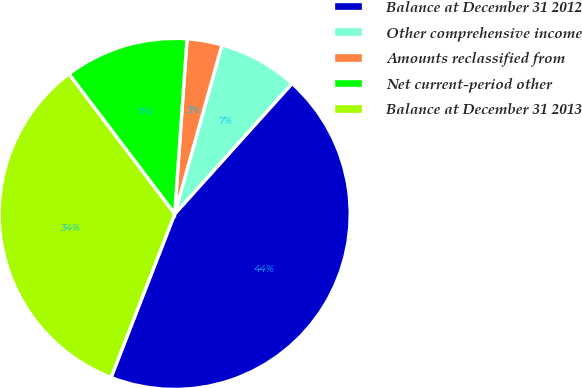<chart> <loc_0><loc_0><loc_500><loc_500><pie_chart><fcel>Balance at December 31 2012<fcel>Other comprehensive income<fcel>Amounts reclassified from<fcel>Net current-period other<fcel>Balance at December 31 2013<nl><fcel>44.25%<fcel>7.32%<fcel>3.22%<fcel>11.42%<fcel>33.79%<nl></chart> 